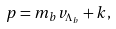Convert formula to latex. <formula><loc_0><loc_0><loc_500><loc_500>p = m _ { b } v _ { \Lambda _ { b } } + k ,</formula> 